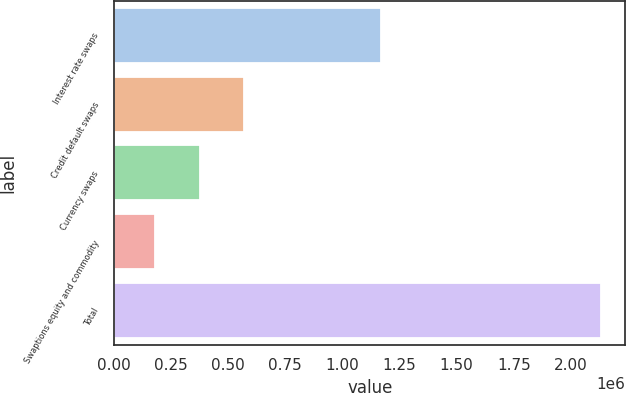<chart> <loc_0><loc_0><loc_500><loc_500><bar_chart><fcel>Interest rate swaps<fcel>Credit default swaps<fcel>Currency swaps<fcel>Swaptions equity and commodity<fcel>Total<nl><fcel>1.16746e+06<fcel>569677<fcel>374322<fcel>178967<fcel>2.13252e+06<nl></chart> 